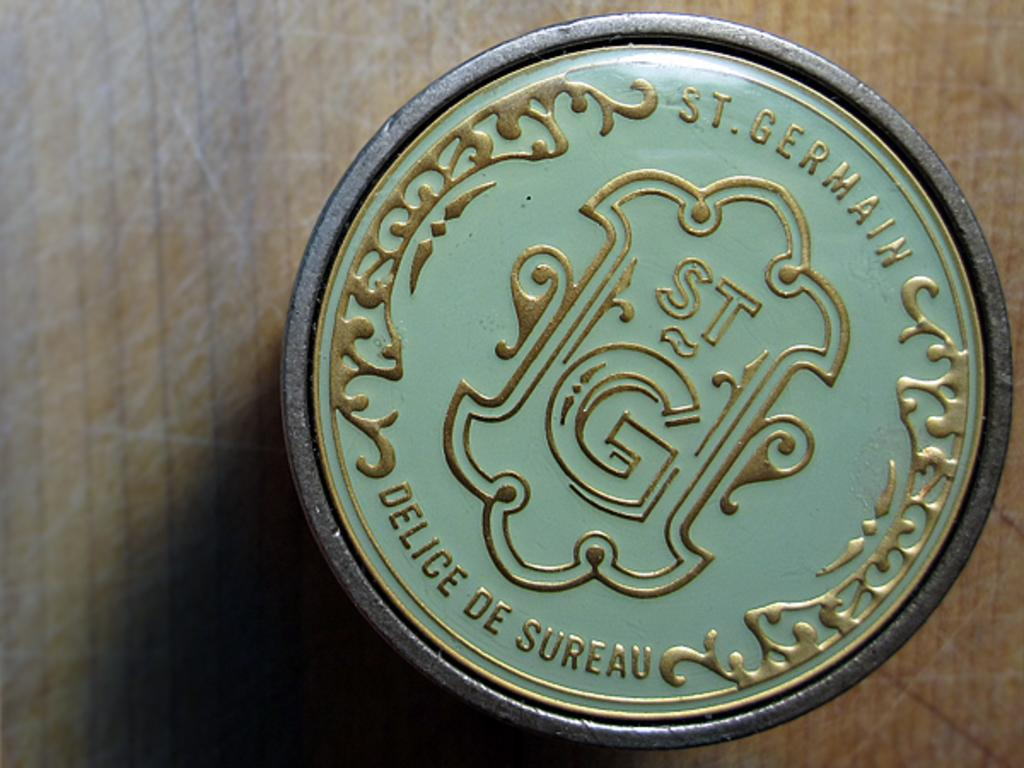Provide a one-sentence caption for the provided image. A green background with gold designs and letters that read, "St. Germain" at the top. 